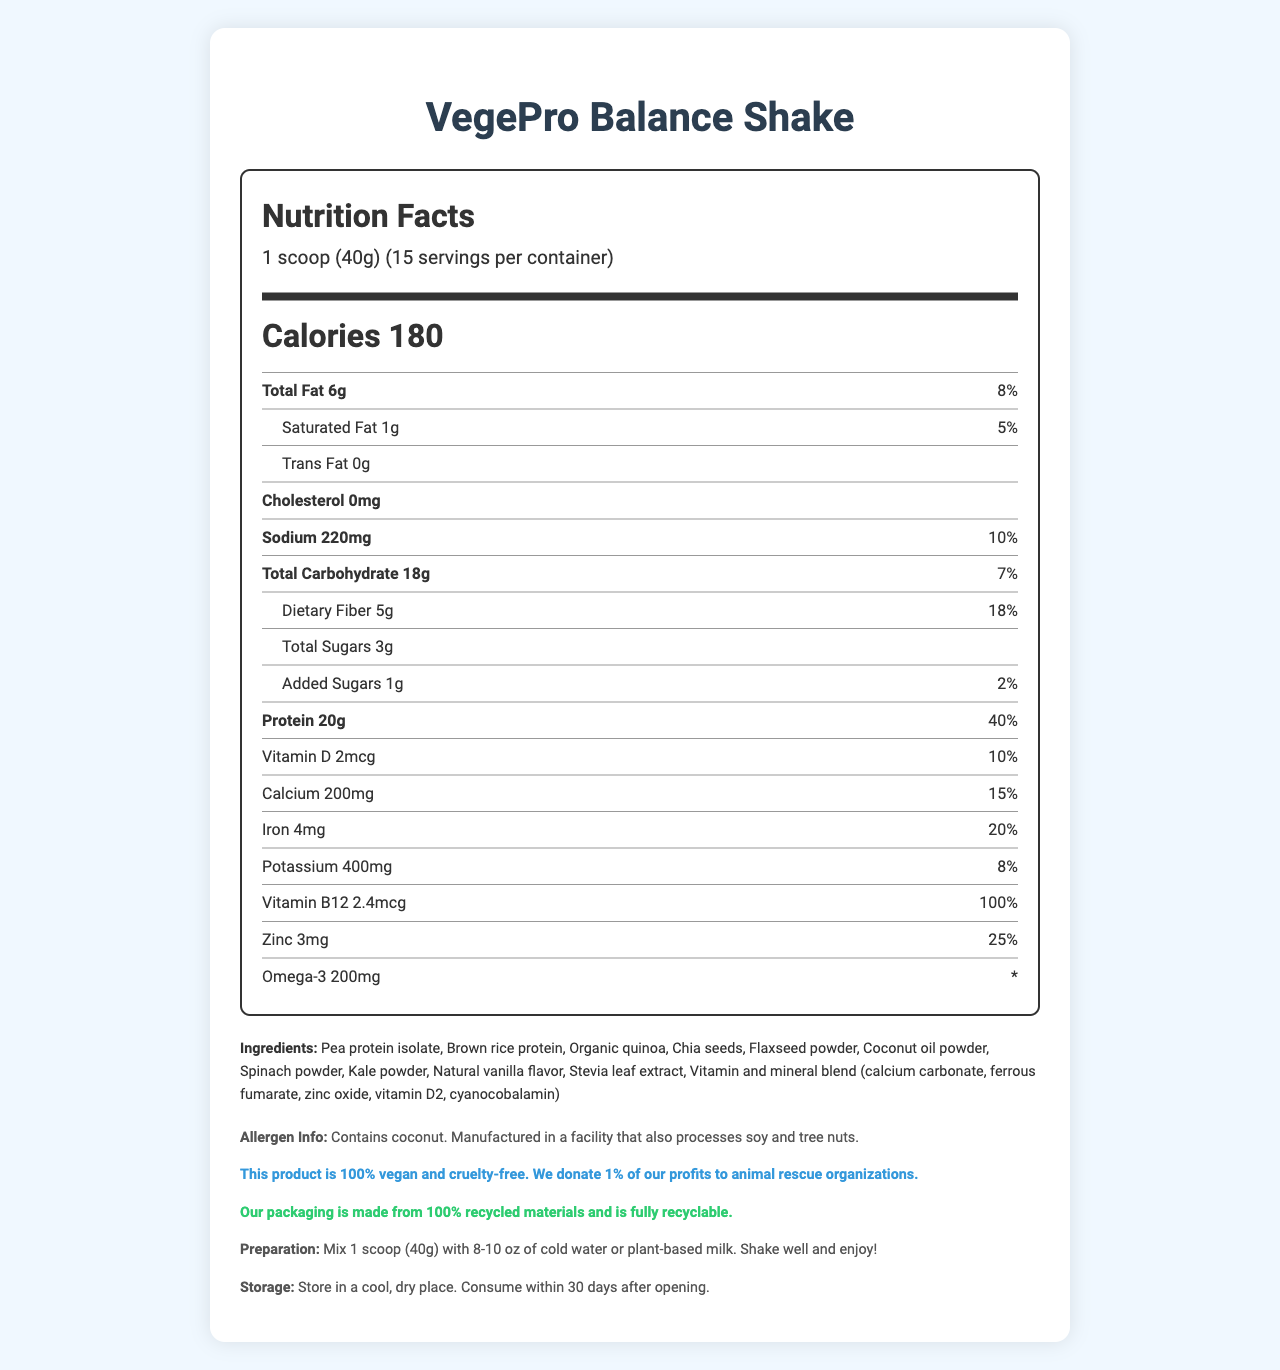what is the product name? The product name can be found at the very top of the document.
Answer: VegePro Balance Shake what is the serving size of the VegePro Balance Shake? The serving size is listed under the "Nutrition Facts" section as "1 scoop (40g)".
Answer: 1 scoop (40g) how many servings are there per container? The number of servings per container is displayed under the serving size in the "Nutrition Facts" section.
Answer: 15 how many calories are there per serving? The number of calories per serving is clearly stated under the calorie section in the "Nutrition Facts".
Answer: 180 what is the total fat content per serving? The total fat content is listed as "6g" with a daily value percentage of "8%" under the "Nutrition Facts".
Answer: 6g (8%) what are the preparation instructions for the shake? The preparation instructions are listed at the bottom of the document under "Preparation".
Answer: Mix 1 scoop (40g) with 8-10 oz of cold water or plant-based milk. Shake well and enjoy! which ingredient provides the primary source of protein? (A) Brown rice protein (B) Pea protein isolate (C) Chia seeds (D) Flaxseed powder The "Ingredients" section lists "Pea protein isolate" as the first ingredient, indicating it's the primary source of protein.
Answer: B what is the percentage of daily value for Zinc in the shake? (A) 15% (B) 20% (C) 25% (D) 30% The daily value for Zinc is listed as "25%" under the "Nutrition Facts".
Answer: C Does the shake contain any cholesterol? The "Nutrition Facts" section lists cholesterol as "0mg", indicating it has no cholesterol.
Answer: No is this product suitable for vegans? The "animal welfare statement" clearly mentions that the product is 100% vegan and cruelty-free.
Answer: Yes what kind of packaging is the product sold in? The "environmental impact" statement mentions that the packaging is made from 100% recycled materials and is fully recyclable.
Answer: 100% recycled materials and fully recyclable does the product contain any tree nuts? The allergen info states the product is manufactured in a facility that processes tree nuts.
Answer: Yes summarize the document. This summary includes the main aspects of the document's content, such as nutritional values, preparation instructions, and additional product information.
Answer: The document provides detailed nutrition facts and other key information about the VegePro Balance Shake, a vegetarian meal replacement shake. It includes serving size, calories, fat, cholesterol, sodium, carbohydrates, protein, vitamins, minerals, ingredients, allergen information, animal welfare statement, environmental impact, preparation, and storage instructions. what is the omega-3 content per serving and its daily value percentage? The nutrition facts state the omega-3 content as 200mg with a daily value denoted by "*", meaning the daily value is not defined.
Answer: 200mg * what is the primary flavoring ingredient used? The "Ingredients" section lists "Natural vanilla flavor" as one of the components, indicating it is used for flavoring.
Answer: Natural vanilla flavor is the information about sourcing of the ingredients provided? The document does not provide any details on the sourcing of the ingredients, only listing them.
Answer: Not enough information 